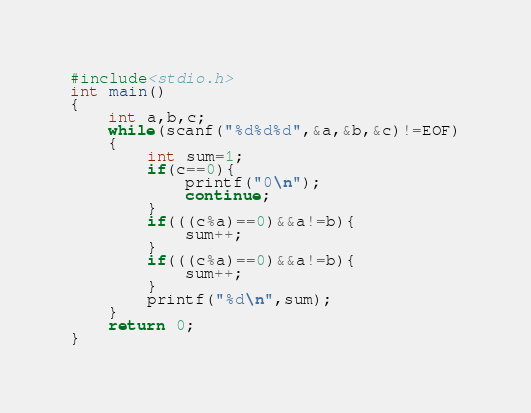Convert code to text. <code><loc_0><loc_0><loc_500><loc_500><_C++_>#include<stdio.h>
int main()
{
	int a,b,c;
	while(scanf("%d%d%d",&a,&b,&c)!=EOF)
	{
		int sum=1;
		if(c==0){
			printf("0\n");
			continue;
		}
		if(((c%a)==0)&&a!=b){
			sum++;
		} 
		if(((c%a)==0)&&a!=b){
			sum++;
		} 
		printf("%d\n",sum);
	}
	return 0; 
}</code> 